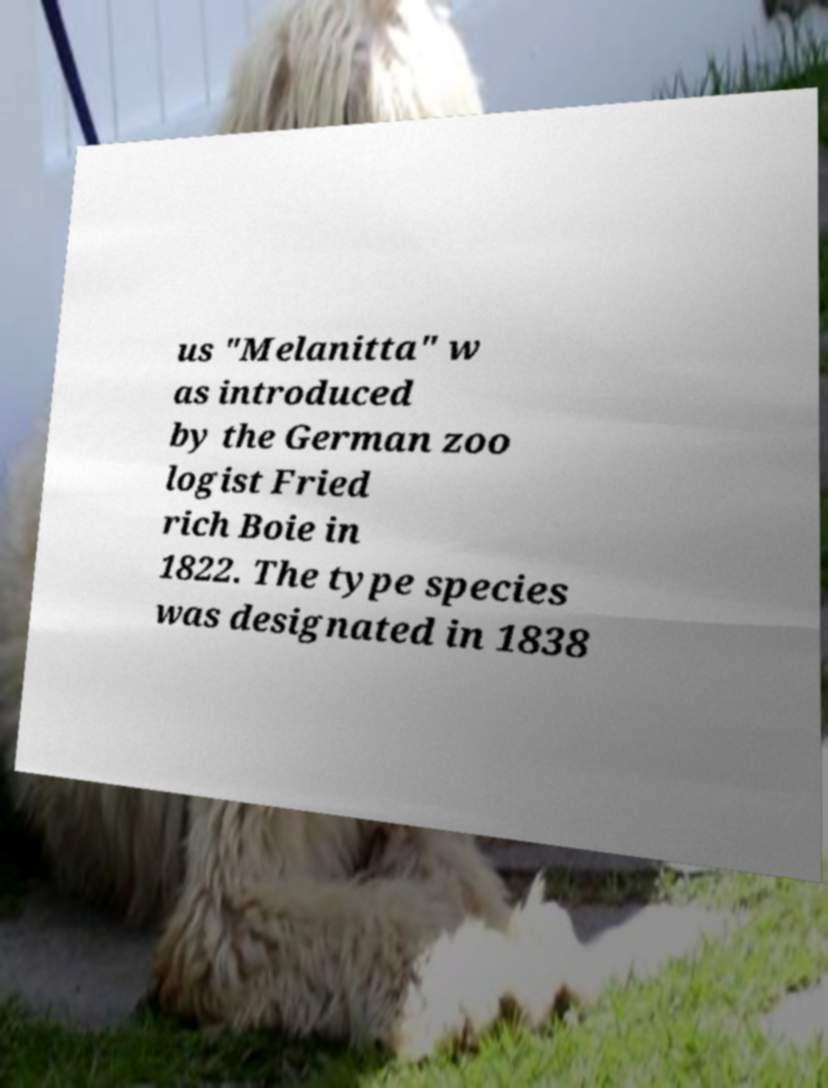There's text embedded in this image that I need extracted. Can you transcribe it verbatim? us "Melanitta" w as introduced by the German zoo logist Fried rich Boie in 1822. The type species was designated in 1838 